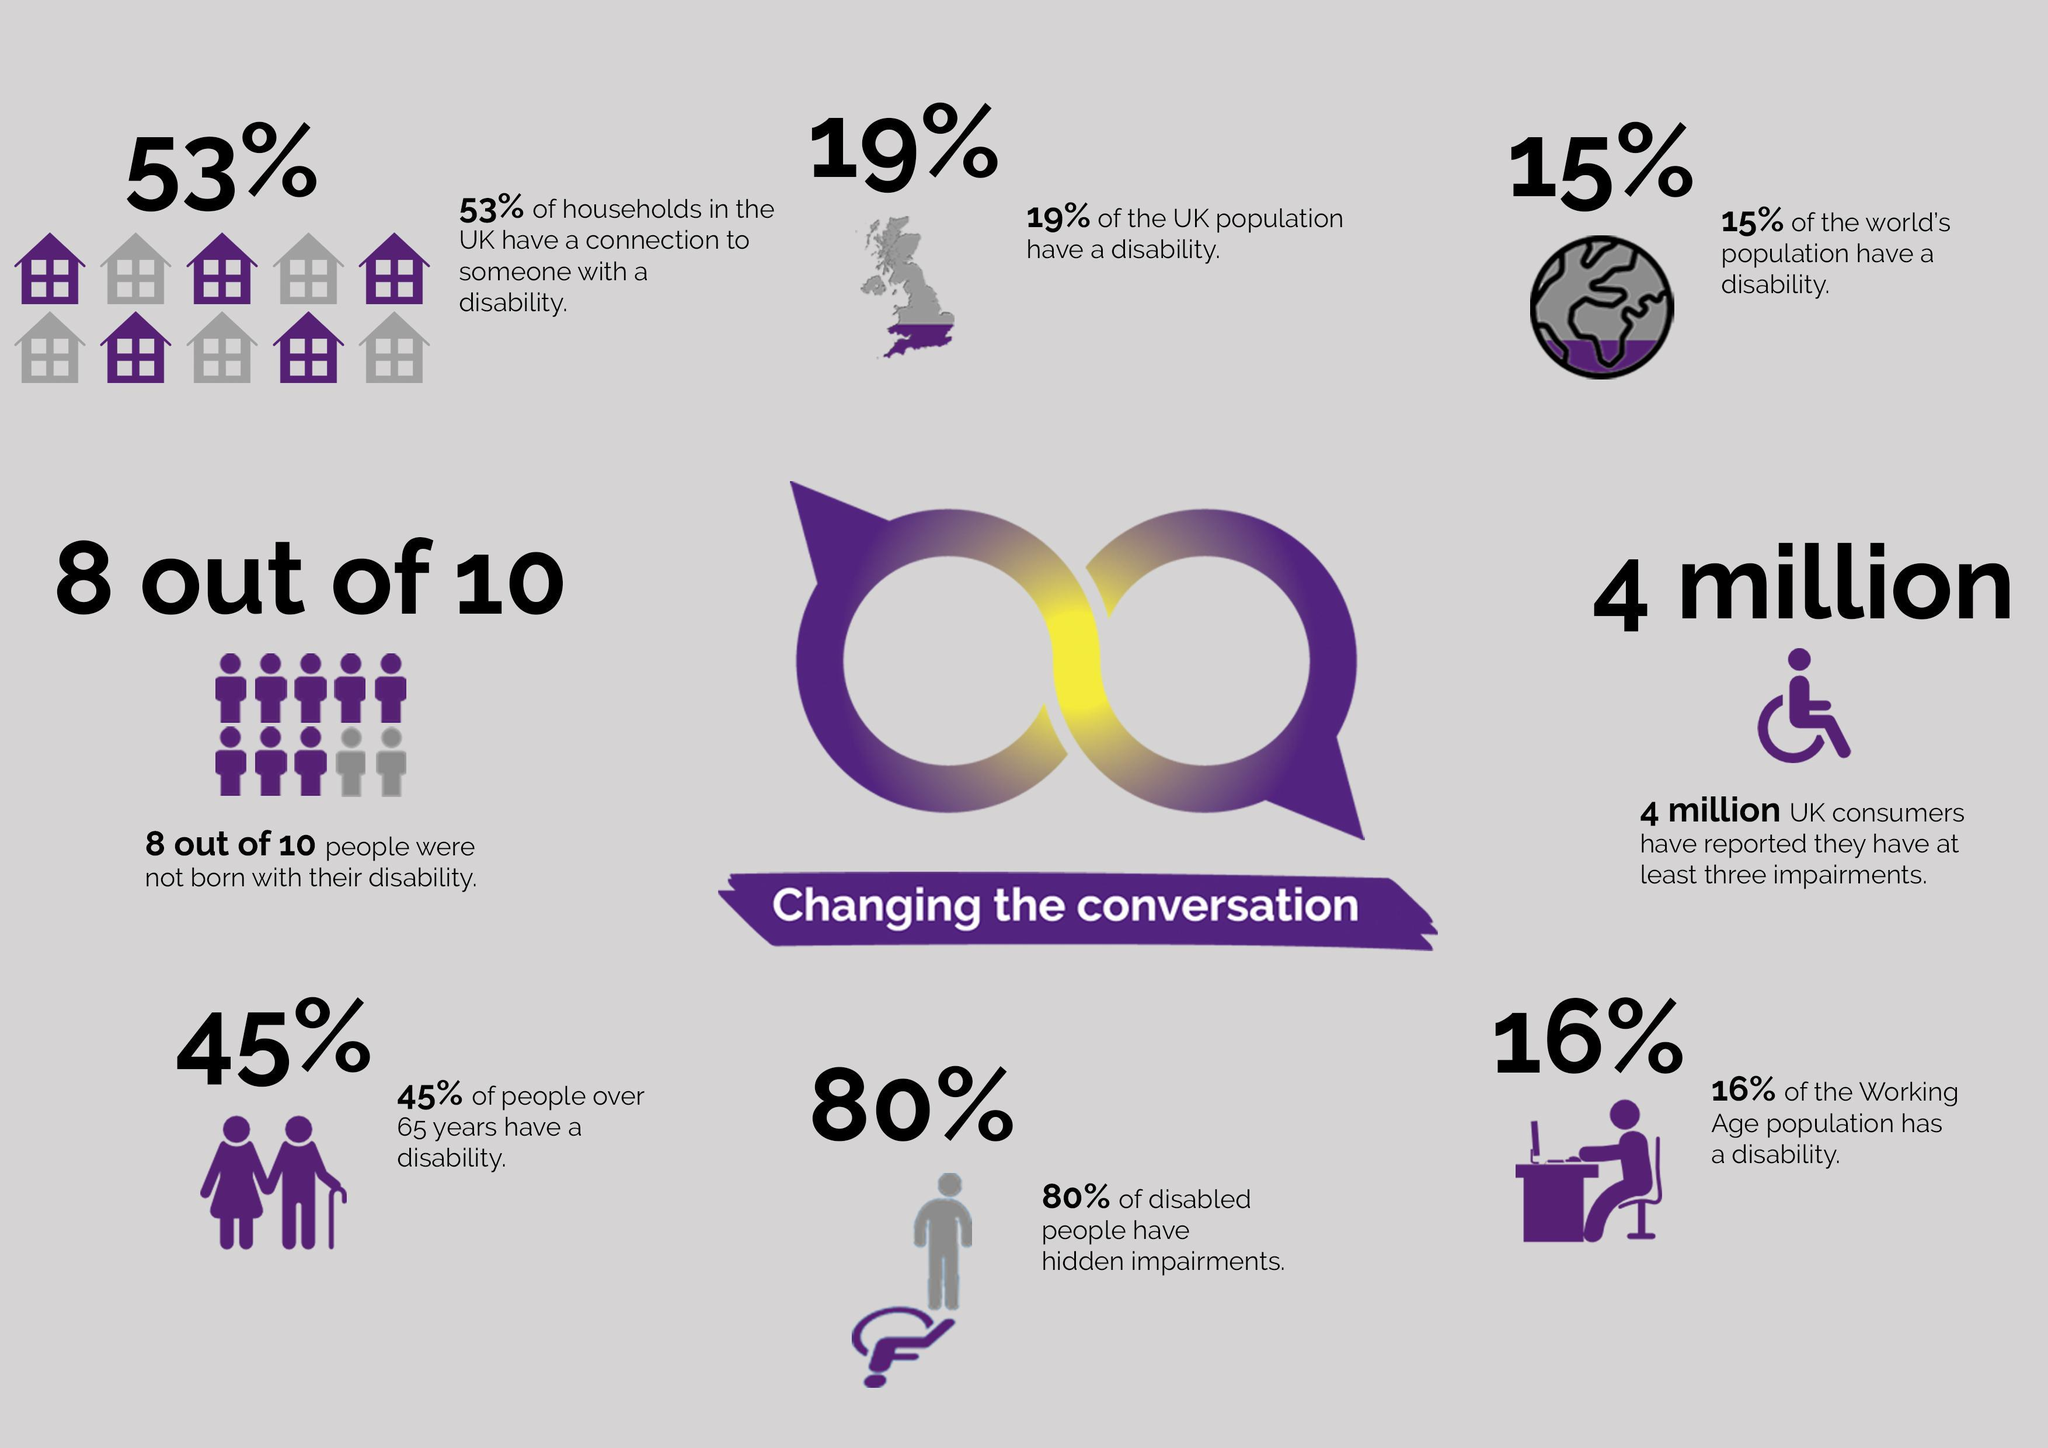What percentage of the world's population does not have a disability?
Answer the question with a short phrase. 85% What percentage of the UK population does not have a disability? 81% 